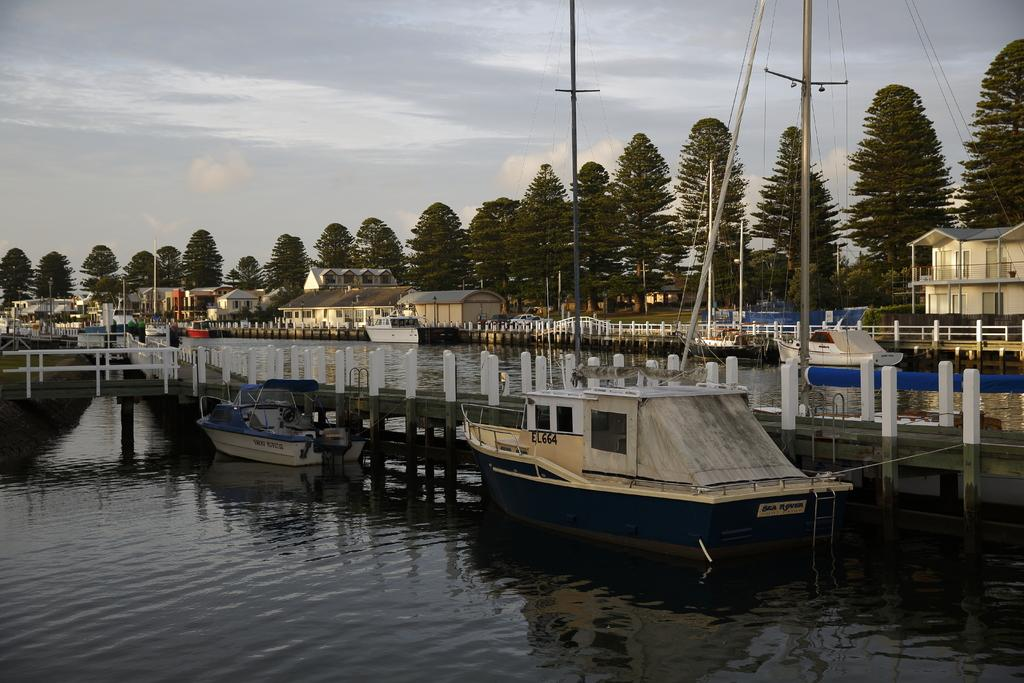What is in the water in the image? There are boats in the water in the image. What can be seen in the background of the image? There are houses and trees in the background. What type of meeting is taking place on the boats in the image? There is no meeting taking place on the boats in the image; it only shows boats in the water. What kind of apparatus can be seen on the boats in the image? There is no apparatus visible on the boats in the image; only the boats themselves are present. 